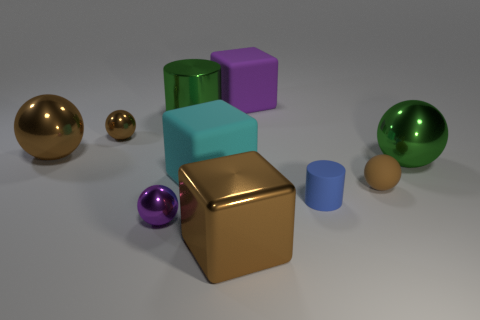What materials do these objects seem to be made of? The objects in this image seem to be made of various materials. The spheres and the rubber sphere have a reflective surface suggesting they could be made of polished metal or plastic. The cubes appear matte and could be made of a solid, non-reflective material like wood or plastic. 